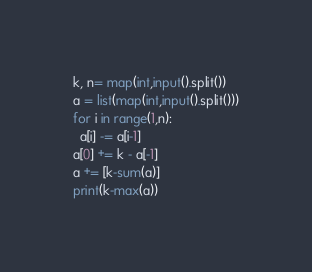<code> <loc_0><loc_0><loc_500><loc_500><_Python_>k, n= map(int,input().split())
a = list(map(int,input().split()))
for i in range(1,n):
  a[i] -= a[i-1]
a[0] += k - a[-1]
a += [k-sum(a)]
print(k-max(a))</code> 